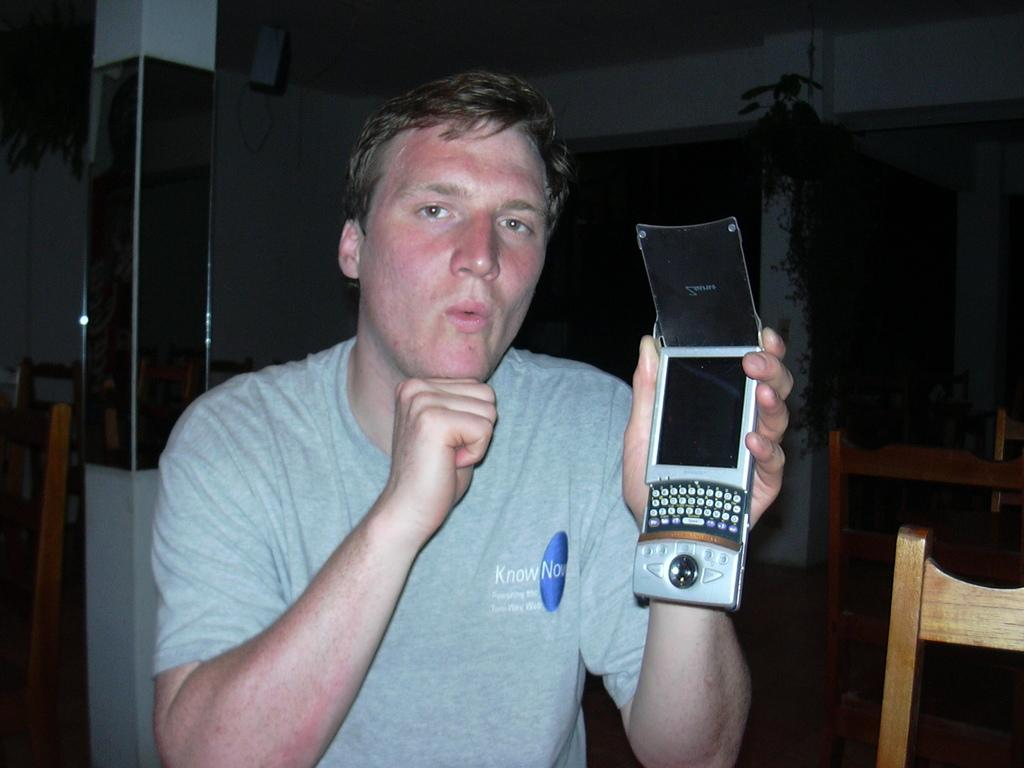What is the person in the image doing? The person is sitting on a chair in the image. What object is the person holding in their hands? The person is holding a mobile phone in their hands. Can you describe the background of the image? There are chairs and a pillar in the background of the image. How many dolls are sitting on the donkey in the image? There are no dolls or donkeys present in the image. 